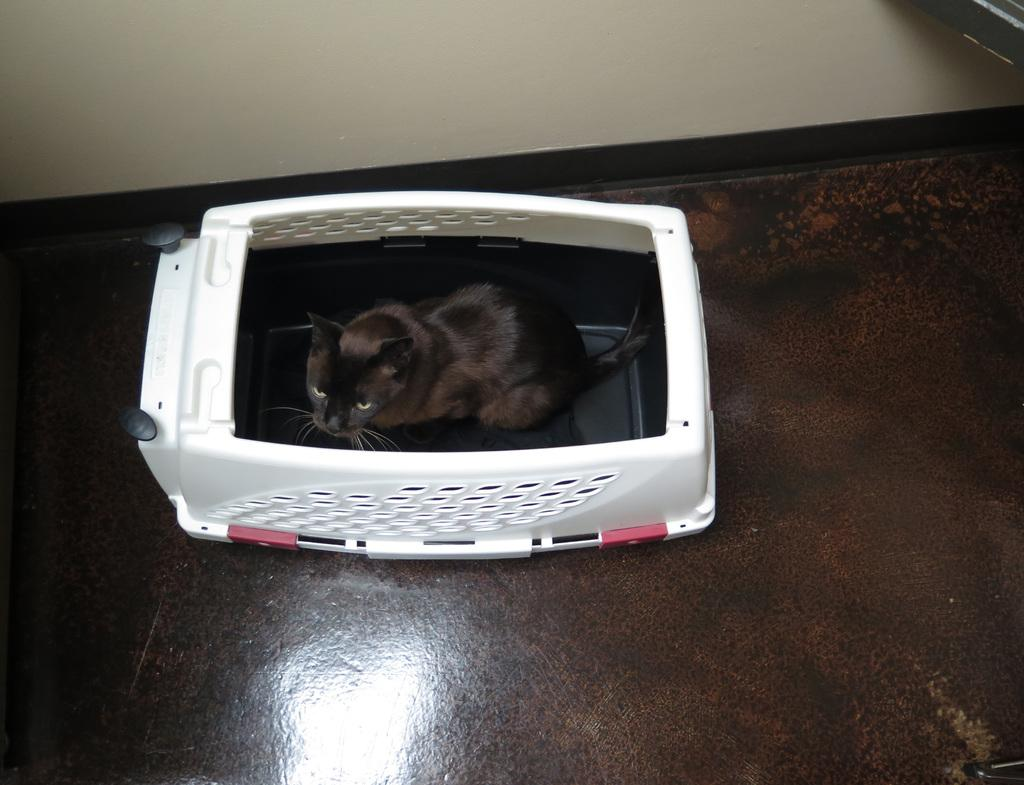What type of animal is present in the image? There is a cat in the image. What is the color of the cat? The cat is black in color. Where is the cat located in the image? The cat is inside a white object. What color is the background wall in the image? The background wall is cream-colored. What type of recess can be seen in the image? There is no recess present in the image; it features a cat inside a white object. How does the cat's memory affect its behavior in the image? The image does not provide any information about the cat's memory or behavior, so it cannot be determined from the image. 